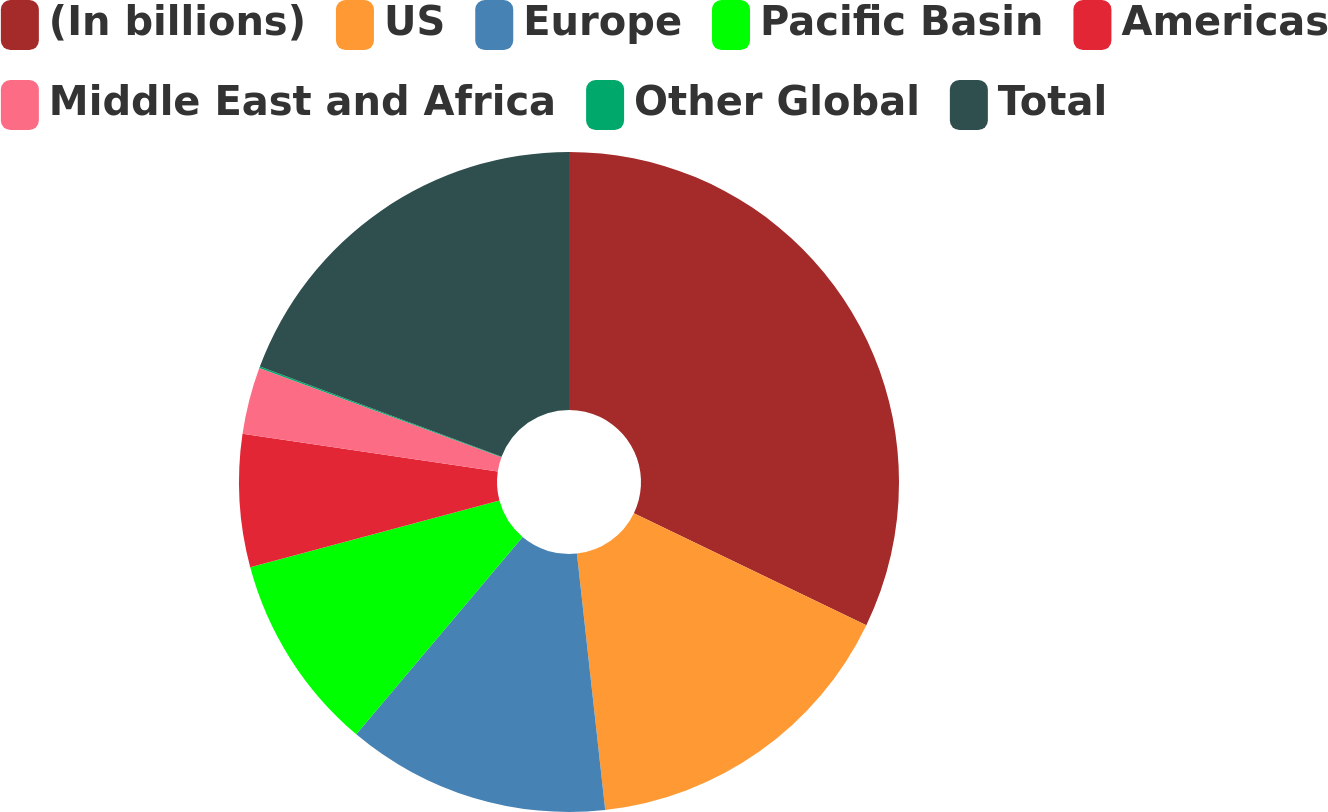Convert chart. <chart><loc_0><loc_0><loc_500><loc_500><pie_chart><fcel>(In billions)<fcel>US<fcel>Europe<fcel>Pacific Basin<fcel>Americas<fcel>Middle East and Africa<fcel>Other Global<fcel>Total<nl><fcel>32.14%<fcel>16.11%<fcel>12.9%<fcel>9.69%<fcel>6.49%<fcel>3.28%<fcel>0.08%<fcel>19.31%<nl></chart> 